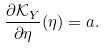Convert formula to latex. <formula><loc_0><loc_0><loc_500><loc_500>\frac { \partial \mathcal { K } _ { Y } } { \partial \eta } ( \eta ) = a .</formula> 